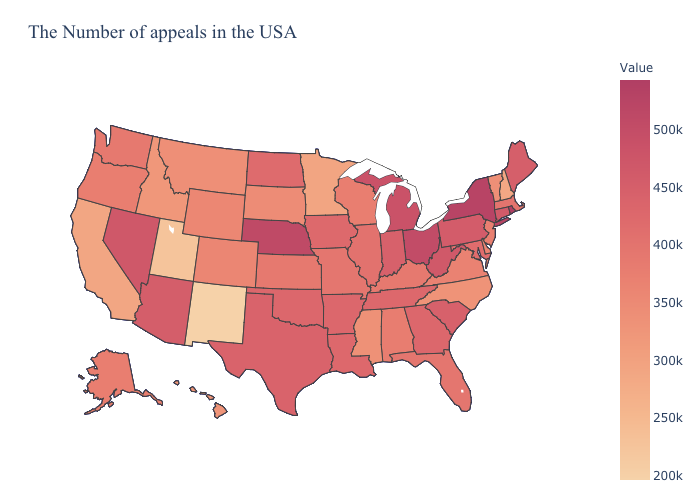Among the states that border Massachusetts , does New Hampshire have the lowest value?
Answer briefly. Yes. Is the legend a continuous bar?
Keep it brief. Yes. Which states have the lowest value in the MidWest?
Short answer required. Minnesota. 